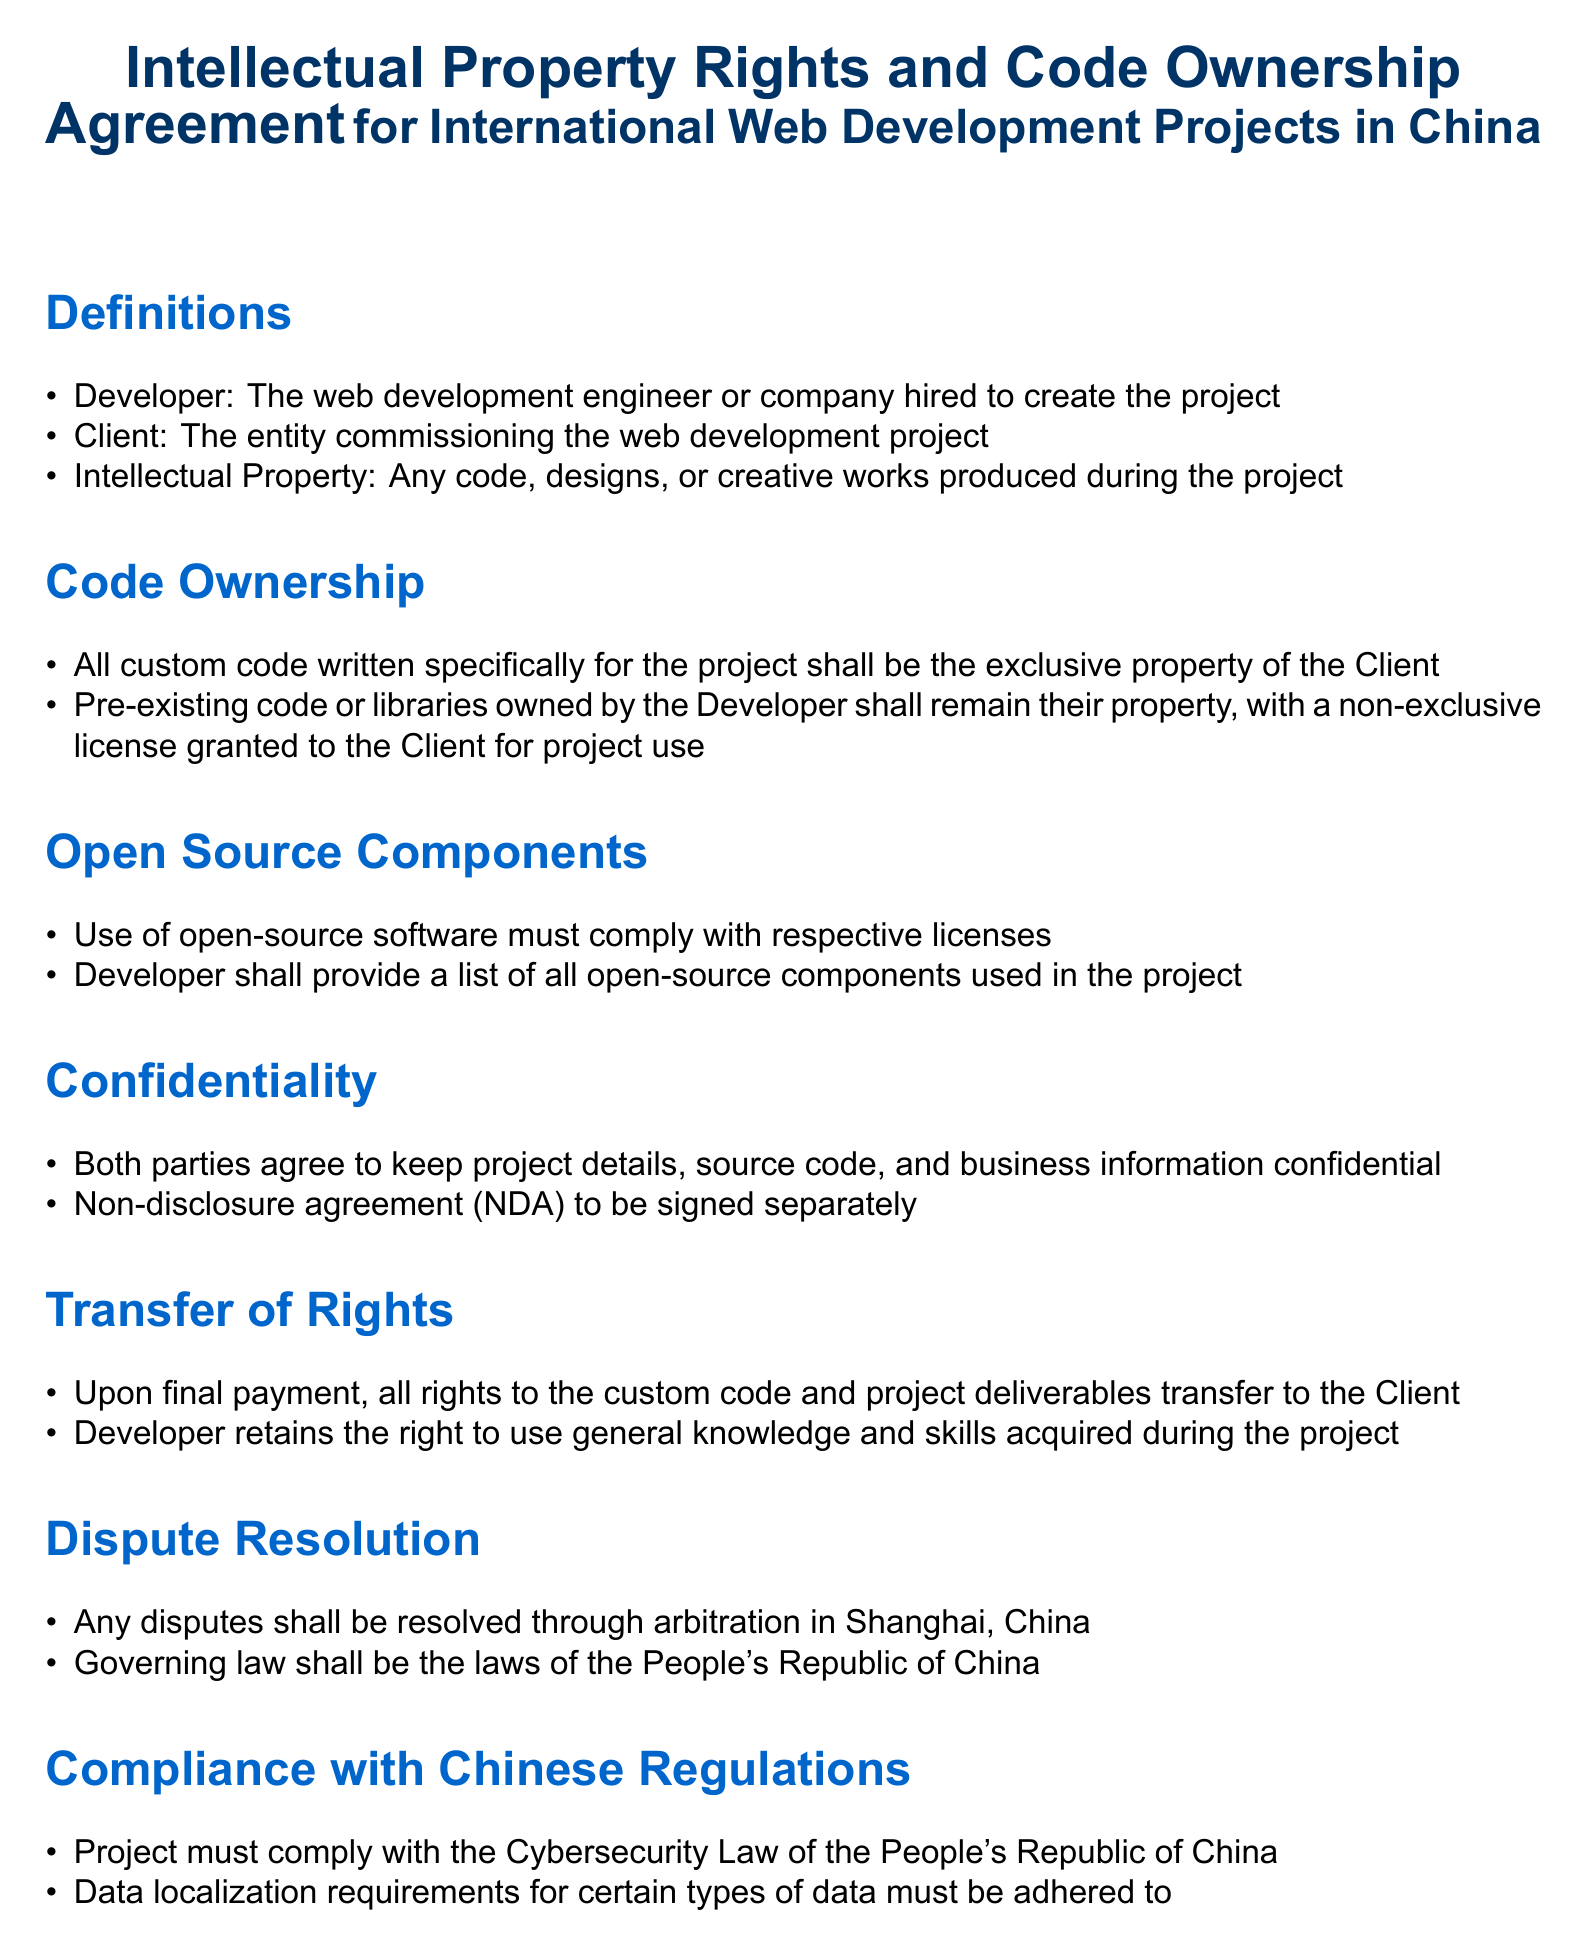What is the title of the document? The title of the document is found at the beginning section and summarizes the main focus of the agreement.
Answer: Intellectual Property Rights and Code Ownership Agreement for International Web Development Projects in China Who is the Developer? The Developer is defined in the document under the Definitions section, describing the role involved in the project.
Answer: The web development engineer or company hired to create the project What must the Developer provide regarding open-source components? This information is specified in the Open Source Components section, outlining the Developer's obligations.
Answer: A list of all open-source components used in the project What happens to the rights of custom code after final payment? This process is described in the Transfer of Rights section, detailing the ownership transfer once the financial obligation is met.
Answer: All rights to the custom code and project deliverables transfer to the Client Where will disputes be resolved? The Dispute Resolution section indicates the location where any disagreements between parties will be settled.
Answer: Shanghai, China What law governs the agreement? This is stated in the Dispute Resolution section, which specifies the legal framework for the contract.
Answer: The laws of the People's Republic of China What type of agreement must be signed for confidentiality? The confidentiality requirements include a specific type of agreement, as mentioned in the Confidentiality section.
Answer: Non-disclosure agreement (NDA) Which law must the project comply with? This compliance requirement is listed in the Compliance with Chinese Regulations section.
Answer: Cybersecurity Law of the People's Republic of China 